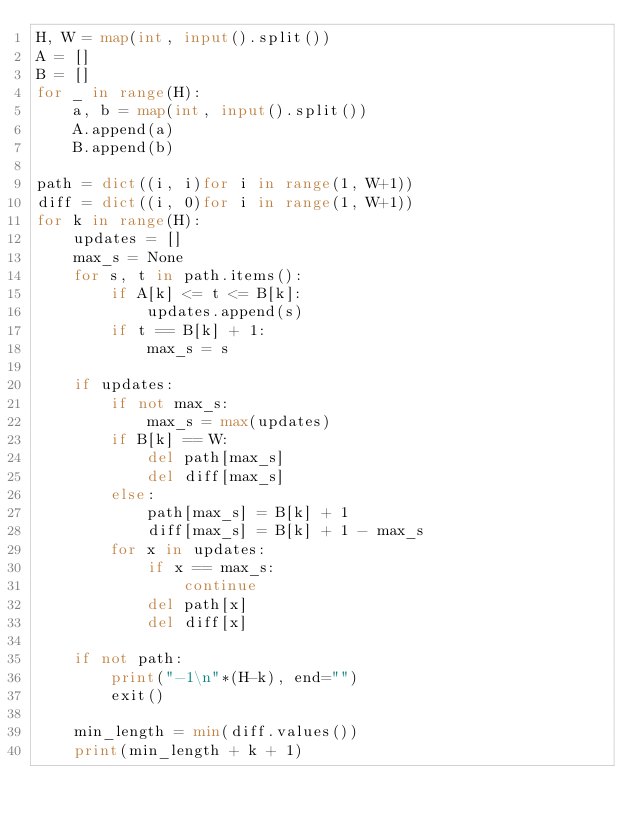<code> <loc_0><loc_0><loc_500><loc_500><_Python_>H, W = map(int, input().split())
A = []
B = []
for _ in range(H):
    a, b = map(int, input().split())
    A.append(a)
    B.append(b)

path = dict((i, i)for i in range(1, W+1))
diff = dict((i, 0)for i in range(1, W+1))
for k in range(H):
    updates = []
    max_s = None
    for s, t in path.items():
        if A[k] <= t <= B[k]:
            updates.append(s)
        if t == B[k] + 1:
            max_s = s

    if updates:
        if not max_s:
            max_s = max(updates)
        if B[k] == W:
            del path[max_s]
            del diff[max_s]
        else:
            path[max_s] = B[k] + 1
            diff[max_s] = B[k] + 1 - max_s
        for x in updates:
            if x == max_s:
                continue
            del path[x]
            del diff[x]

    if not path:
        print("-1\n"*(H-k), end="")
        exit()

    min_length = min(diff.values())
    print(min_length + k + 1)</code> 